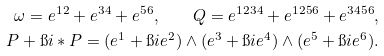<formula> <loc_0><loc_0><loc_500><loc_500>\omega = e ^ { 1 2 } + e ^ { 3 4 } + e ^ { 5 6 } , \quad Q = e ^ { 1 2 3 4 } + e ^ { 1 2 5 6 } + e ^ { 3 4 5 6 } , \\ P + \i i \ast P = ( e ^ { 1 } + \i i e ^ { 2 } ) \wedge ( e ^ { 3 } + \i i e ^ { 4 } ) \wedge ( e ^ { 5 } + \i i e ^ { 6 } ) .</formula> 